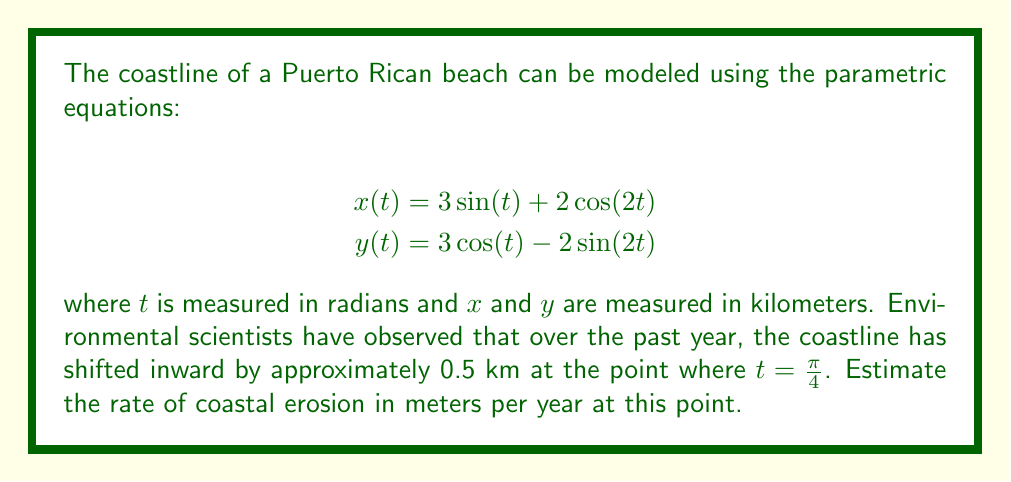Show me your answer to this math problem. To solve this problem, we need to follow these steps:

1) First, we need to find the velocity vector at the point where $t = \frac{\pi}{4}$. This will give us the direction of the coastline's movement.

2) The velocity vector is given by the derivatives of $x(t)$ and $y(t)$ with respect to $t$:

   $$\frac{dx}{dt} = 3\cos(t) - 4\sin(2t)$$
   $$\frac{dy}{dt} = -3\sin(t) - 4\cos(2t)$$

3) Now, we evaluate these at $t = \frac{\pi}{4}$:

   $$\frac{dx}{dt}(\frac{\pi}{4}) = 3\cos(\frac{\pi}{4}) - 4\sin(\frac{\pi}{2}) = 3\cdot\frac{\sqrt{2}}{2} - 4 = 3\frac{\sqrt{2}}{2} - 4$$
   $$\frac{dy}{dt}(\frac{\pi}{4}) = -3\sin(\frac{\pi}{4}) - 4\cos(\frac{\pi}{2}) = -3\cdot\frac{\sqrt{2}}{2} - 0 = -3\frac{\sqrt{2}}{2}$$

4) The velocity vector at this point is:

   $$\vec{v} = (3\frac{\sqrt{2}}{2} - 4, -3\frac{\sqrt{2}}{2})$$

5) To find the direction of erosion, we need the unit vector perpendicular to this velocity vector, pointing inward. We can get this by rotating the velocity vector 90° clockwise and normalizing it:

   $$\vec{n} = \frac{(3\frac{\sqrt{2}}{2}, 3\frac{\sqrt{2}}{2} - 4)}{\sqrt{(3\frac{\sqrt{2}}{2})^2 + (3\frac{\sqrt{2}}{2} - 4)^2}}$$

6) The erosion rate in the direction of $\vec{n}$ is 0.5 km per year. To find the magnitude of the erosion vector, we divide 0.5 by the magnitude of $\vec{n}$:

   $$\text{Erosion rate} = \frac{0.5}{\sqrt{(3\frac{\sqrt{2}}{2})^2 + (3\frac{\sqrt{2}}{2} - 4)^2}} \approx 0.3849 \text{ km/year}$$

7) Converting to meters per year:

   $$0.3849 \text{ km/year} \times 1000 \text{ m/km} \approx 384.9 \text{ m/year}$$
Answer: The estimated rate of coastal erosion is approximately 384.9 meters per year. 